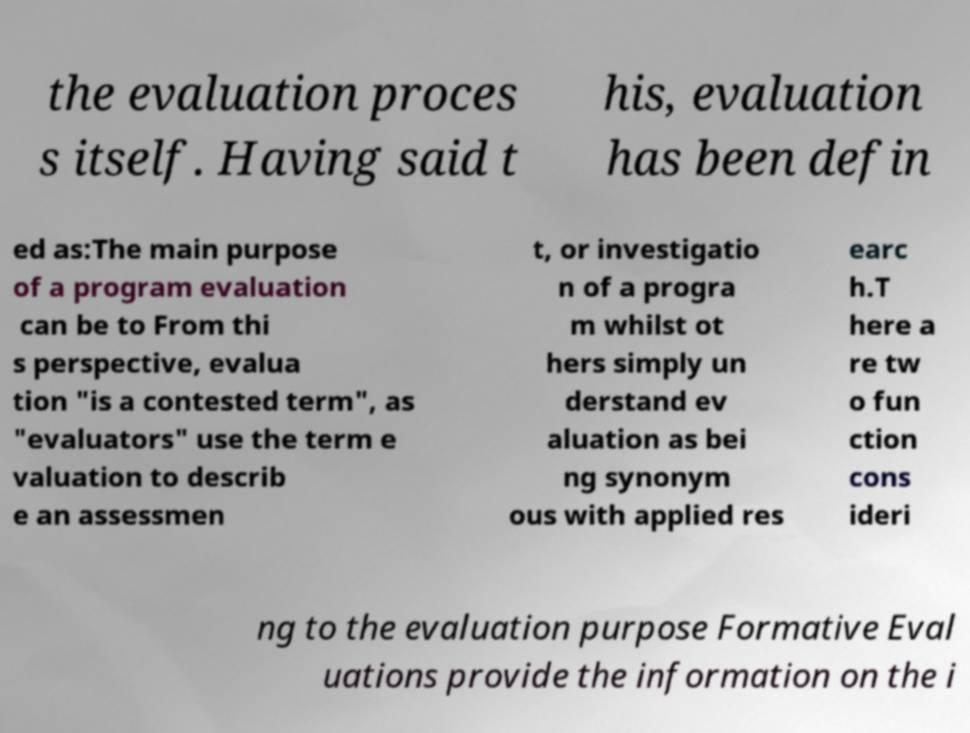There's text embedded in this image that I need extracted. Can you transcribe it verbatim? the evaluation proces s itself. Having said t his, evaluation has been defin ed as:The main purpose of a program evaluation can be to From thi s perspective, evalua tion "is a contested term", as "evaluators" use the term e valuation to describ e an assessmen t, or investigatio n of a progra m whilst ot hers simply un derstand ev aluation as bei ng synonym ous with applied res earc h.T here a re tw o fun ction cons ideri ng to the evaluation purpose Formative Eval uations provide the information on the i 